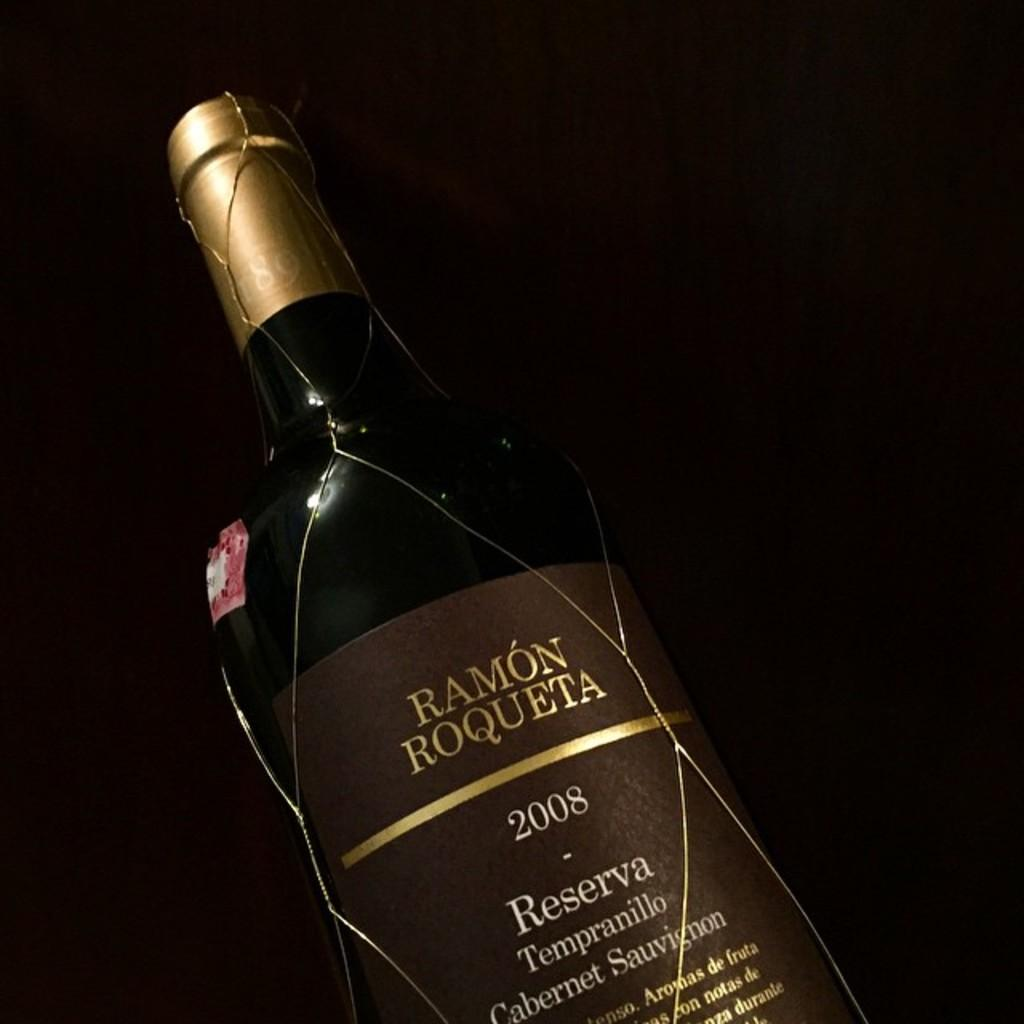Provide a one-sentence caption for the provided image. A 2008 bottle of Ramon Roqueta reserva all by itself. 